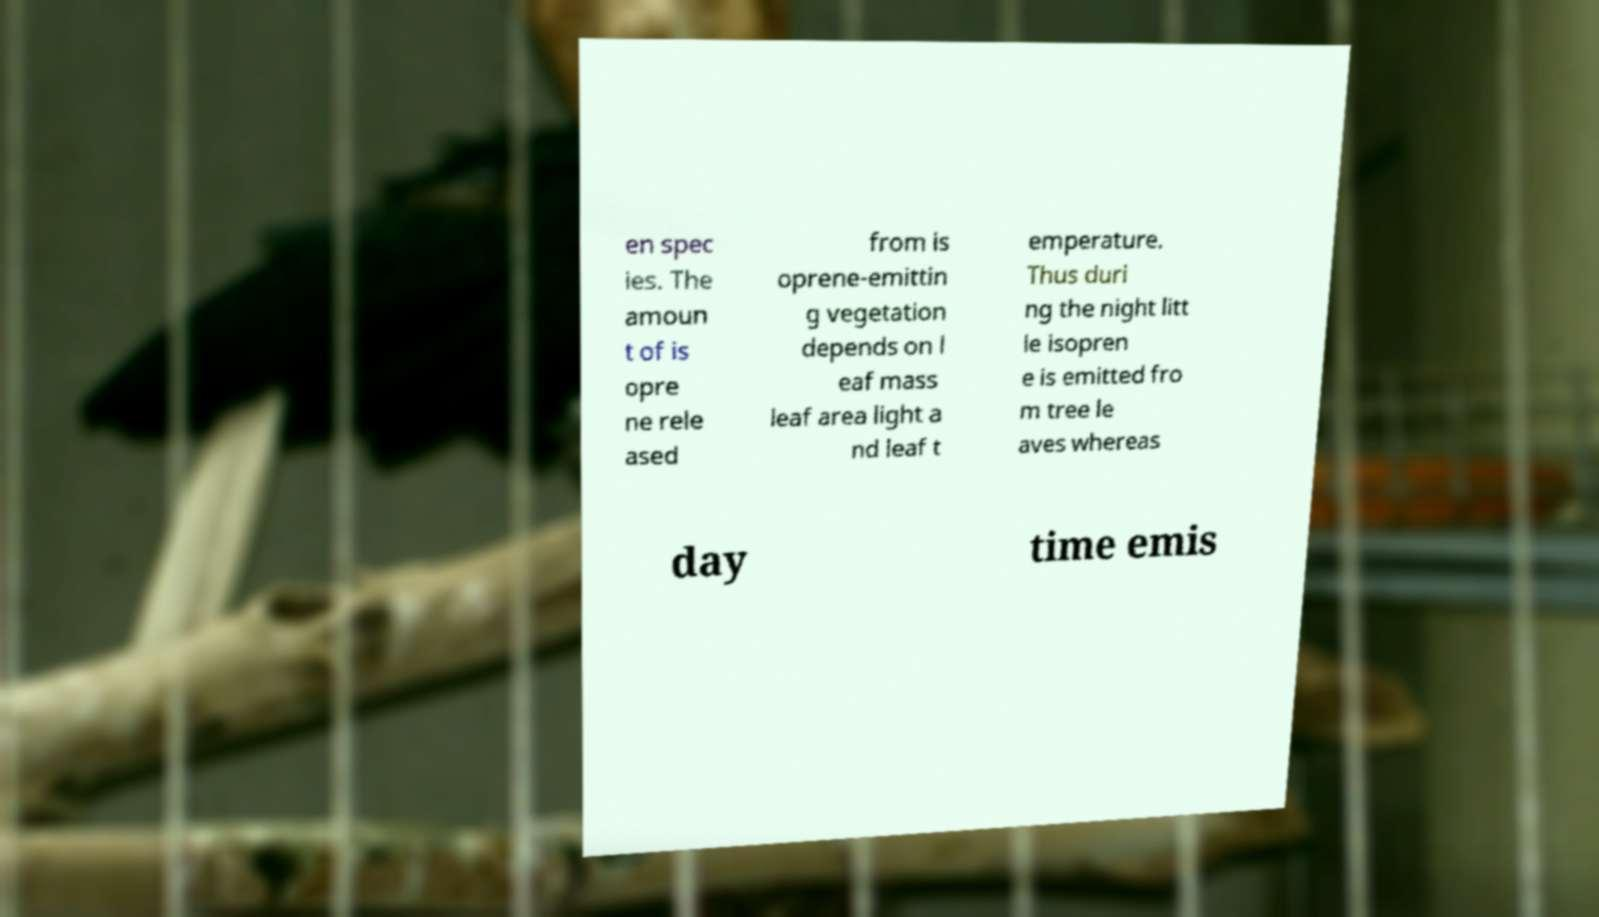Could you extract and type out the text from this image? en spec ies. The amoun t of is opre ne rele ased from is oprene-emittin g vegetation depends on l eaf mass leaf area light a nd leaf t emperature. Thus duri ng the night litt le isopren e is emitted fro m tree le aves whereas day time emis 